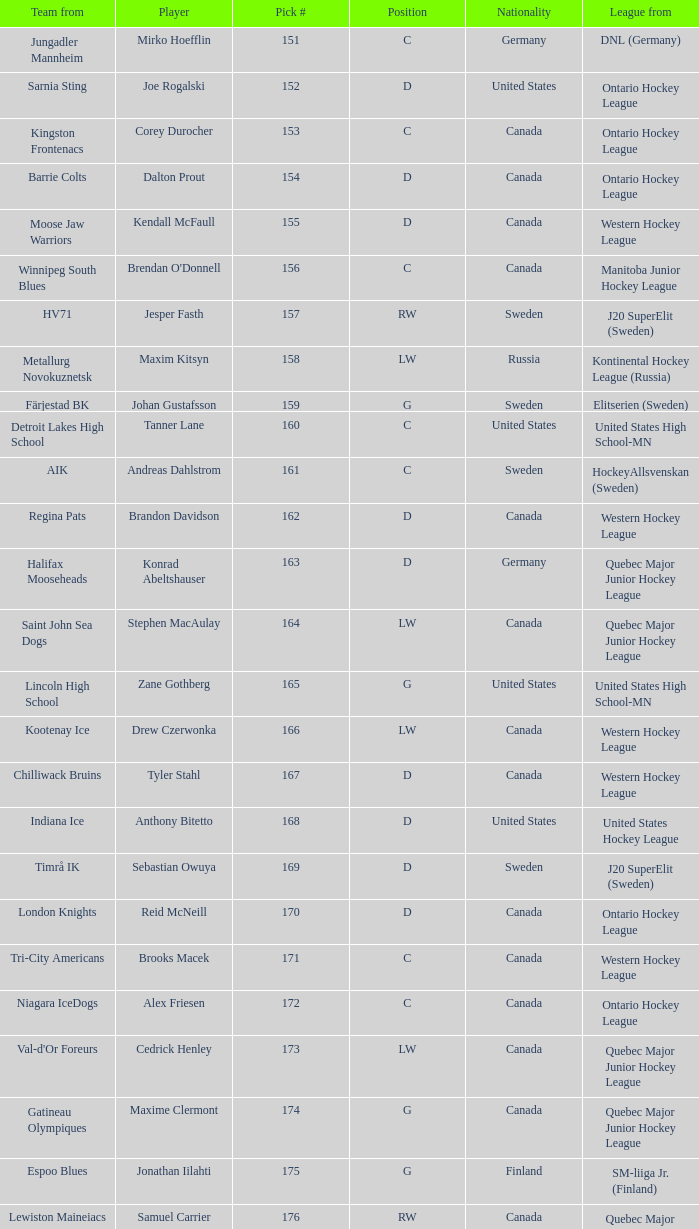What is the average pick # from the Quebec Major Junior Hockey League player Samuel Carrier? 176.0. Parse the full table. {'header': ['Team from', 'Player', 'Pick #', 'Position', 'Nationality', 'League from'], 'rows': [['Jungadler Mannheim', 'Mirko Hoefflin', '151', 'C', 'Germany', 'DNL (Germany)'], ['Sarnia Sting', 'Joe Rogalski', '152', 'D', 'United States', 'Ontario Hockey League'], ['Kingston Frontenacs', 'Corey Durocher', '153', 'C', 'Canada', 'Ontario Hockey League'], ['Barrie Colts', 'Dalton Prout', '154', 'D', 'Canada', 'Ontario Hockey League'], ['Moose Jaw Warriors', 'Kendall McFaull', '155', 'D', 'Canada', 'Western Hockey League'], ['Winnipeg South Blues', "Brendan O'Donnell", '156', 'C', 'Canada', 'Manitoba Junior Hockey League'], ['HV71', 'Jesper Fasth', '157', 'RW', 'Sweden', 'J20 SuperElit (Sweden)'], ['Metallurg Novokuznetsk', 'Maxim Kitsyn', '158', 'LW', 'Russia', 'Kontinental Hockey League (Russia)'], ['Färjestad BK', 'Johan Gustafsson', '159', 'G', 'Sweden', 'Elitserien (Sweden)'], ['Detroit Lakes High School', 'Tanner Lane', '160', 'C', 'United States', 'United States High School-MN'], ['AIK', 'Andreas Dahlstrom', '161', 'C', 'Sweden', 'HockeyAllsvenskan (Sweden)'], ['Regina Pats', 'Brandon Davidson', '162', 'D', 'Canada', 'Western Hockey League'], ['Halifax Mooseheads', 'Konrad Abeltshauser', '163', 'D', 'Germany', 'Quebec Major Junior Hockey League'], ['Saint John Sea Dogs', 'Stephen MacAulay', '164', 'LW', 'Canada', 'Quebec Major Junior Hockey League'], ['Lincoln High School', 'Zane Gothberg', '165', 'G', 'United States', 'United States High School-MN'], ['Kootenay Ice', 'Drew Czerwonka', '166', 'LW', 'Canada', 'Western Hockey League'], ['Chilliwack Bruins', 'Tyler Stahl', '167', 'D', 'Canada', 'Western Hockey League'], ['Indiana Ice', 'Anthony Bitetto', '168', 'D', 'United States', 'United States Hockey League'], ['Timrå IK', 'Sebastian Owuya', '169', 'D', 'Sweden', 'J20 SuperElit (Sweden)'], ['London Knights', 'Reid McNeill', '170', 'D', 'Canada', 'Ontario Hockey League'], ['Tri-City Americans', 'Brooks Macek', '171', 'C', 'Canada', 'Western Hockey League'], ['Niagara IceDogs', 'Alex Friesen', '172', 'C', 'Canada', 'Ontario Hockey League'], ["Val-d'Or Foreurs", 'Cedrick Henley', '173', 'LW', 'Canada', 'Quebec Major Junior Hockey League'], ['Gatineau Olympiques', 'Maxime Clermont', '174', 'G', 'Canada', 'Quebec Major Junior Hockey League'], ['Espoo Blues', 'Jonathan Iilahti', '175', 'G', 'Finland', 'SM-liiga Jr. (Finland)'], ['Lewiston Maineiacs', 'Samuel Carrier', '176', 'RW', 'Canada', 'Quebec Major Junior Hockey League'], ['Chicago Steel', 'Kevin Lind', '177', 'D', 'United States', 'United States Hockey League'], ['Brandon Wheat Kings', 'Mark Stone', '178', 'RW', 'Canada', 'Western Hockey League'], ['The Gunnery', 'Nicholas Luukko', '179', 'D', 'United States', 'United States High School-CT'], ['Indiana Ice', 'Nick Mattson', '180', 'D', 'United States', 'United States Hockey League']]} 